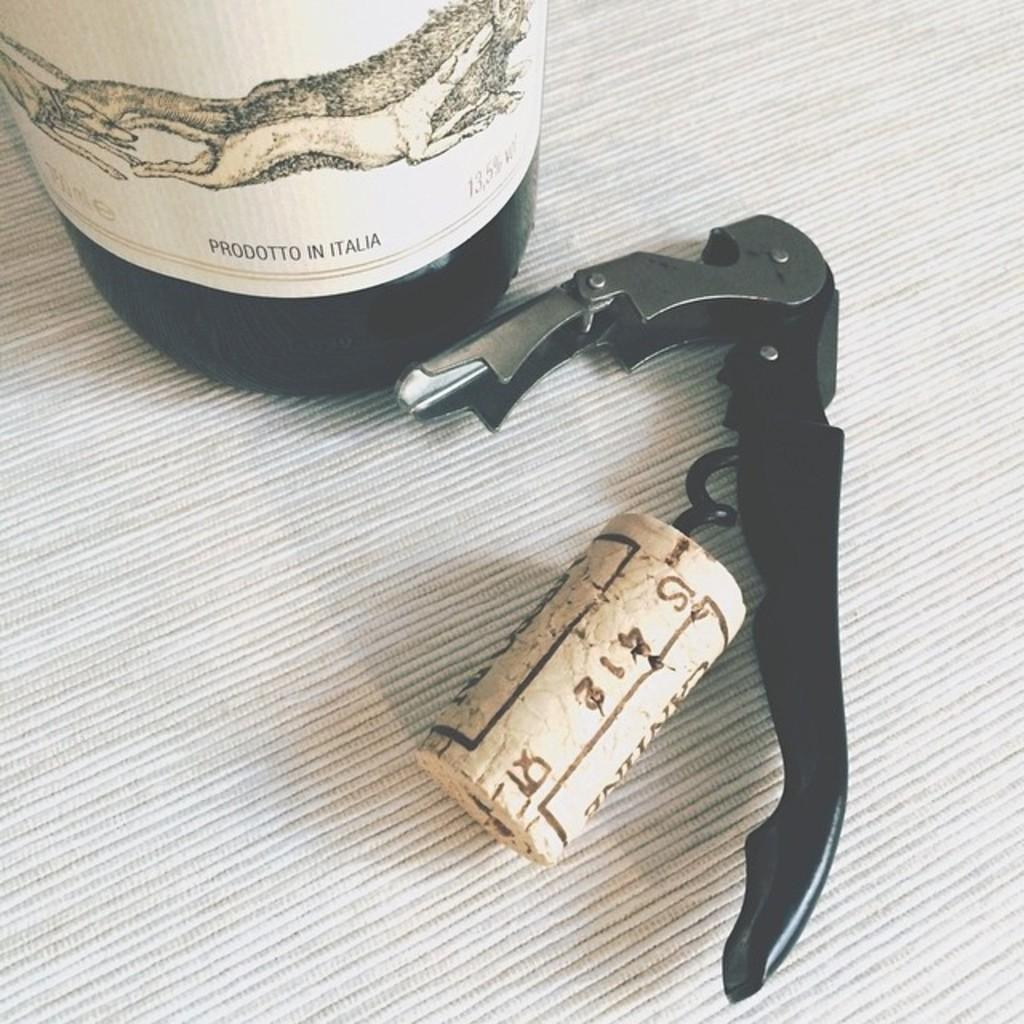What is located in the right corner of the image? There is a black color object in the right corner of the image. What is in the left top corner of the image? There is a glass bottle in the left top corner of the image. What can be seen on the glass bottle? The glass bottle has something written on it. Can you tell me how many mittens are on the black object in the image? There are no mittens present in the image. What type of gun is depicted on the glass bottle? There is no gun depicted on the glass bottle; it only has something written on it. 